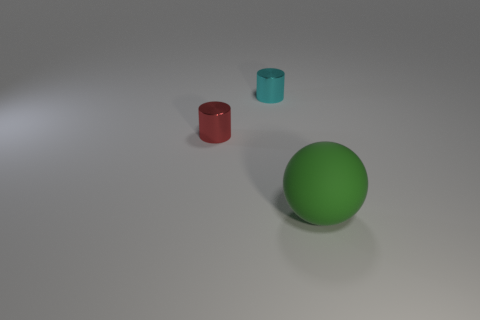What can you deduce about the lighting in this scene? The scene appears to be softly lit with diffuse lighting, creating gentle shadows to the right of the objects, suggesting the light source is to the left. 